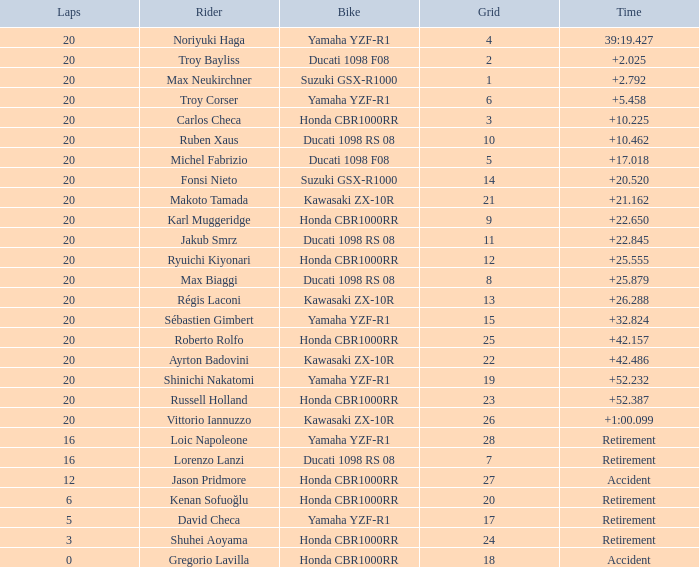What is the time of Max Biaggi with more than 2 grids, 20 laps? 25.879. 